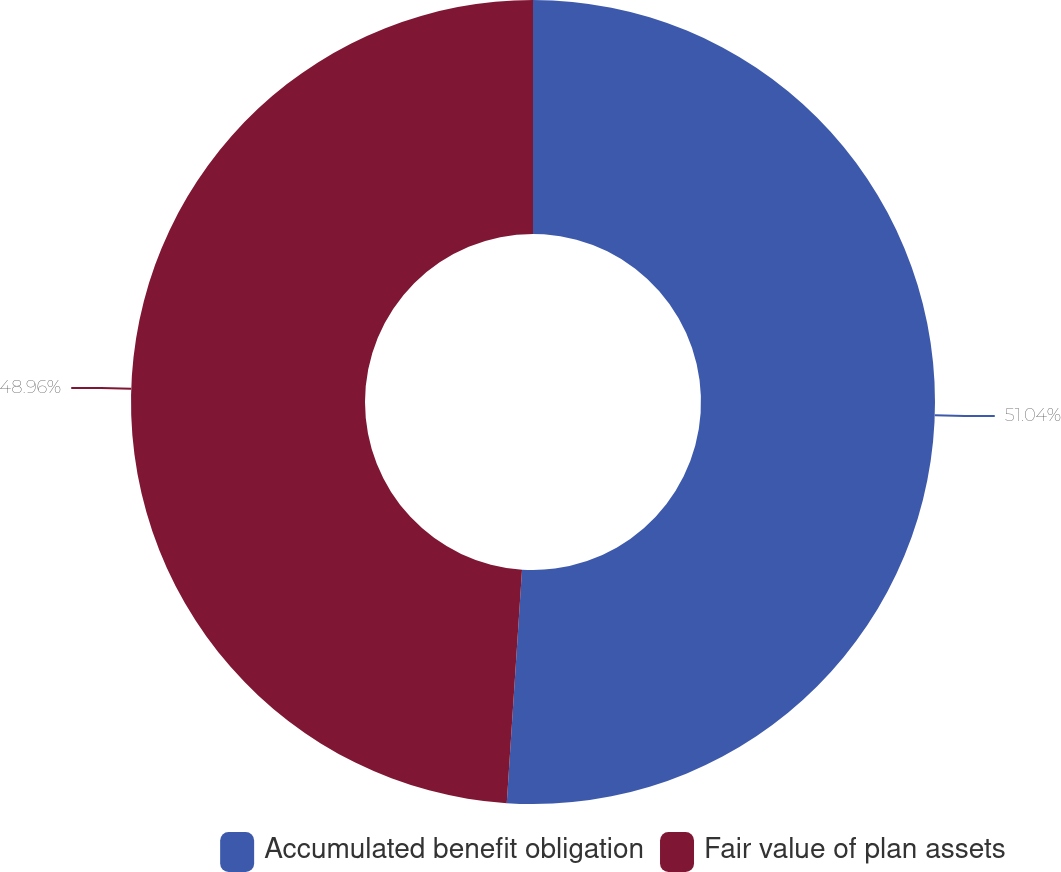Convert chart. <chart><loc_0><loc_0><loc_500><loc_500><pie_chart><fcel>Accumulated benefit obligation<fcel>Fair value of plan assets<nl><fcel>51.04%<fcel>48.96%<nl></chart> 